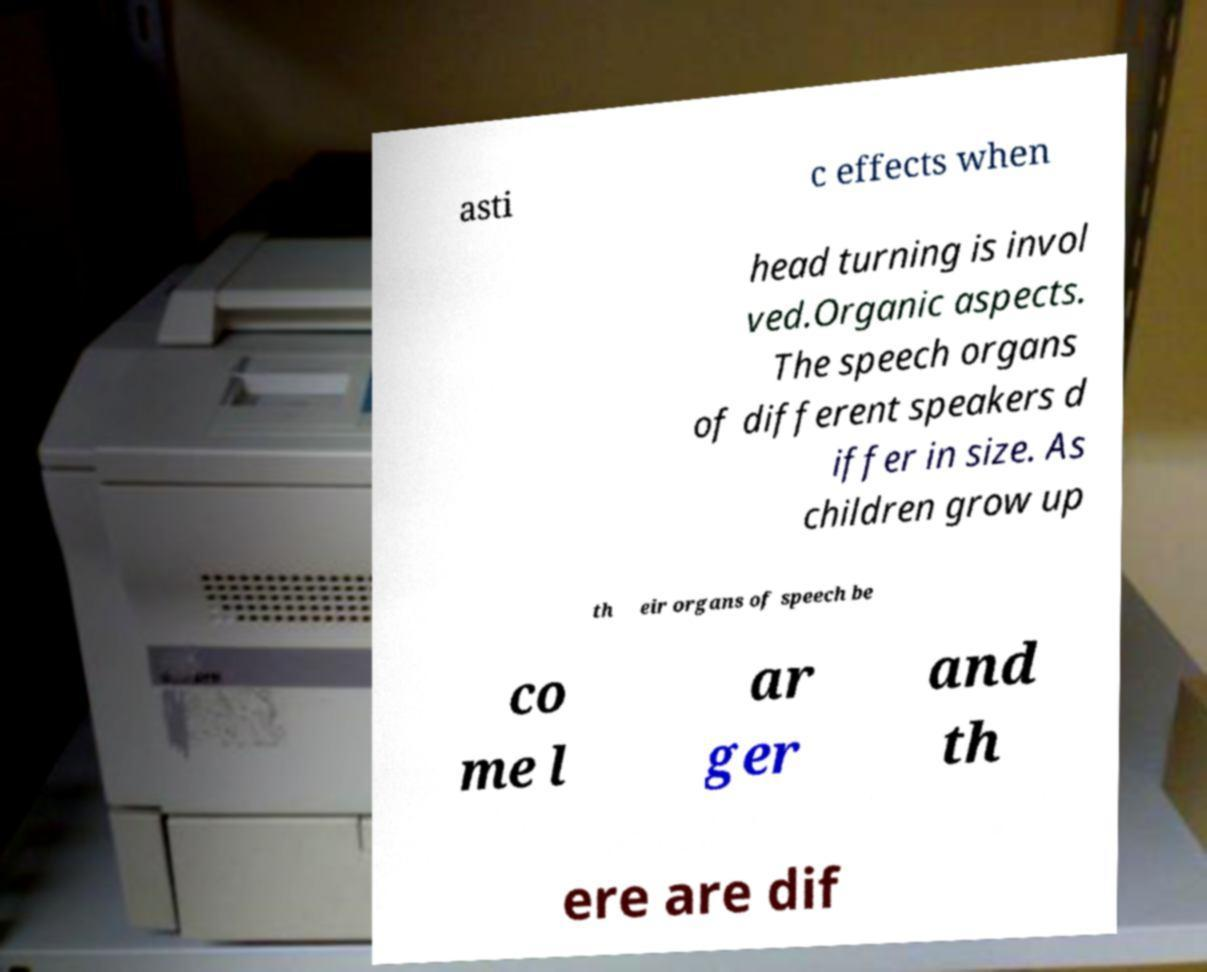Can you accurately transcribe the text from the provided image for me? asti c effects when head turning is invol ved.Organic aspects. The speech organs of different speakers d iffer in size. As children grow up th eir organs of speech be co me l ar ger and th ere are dif 